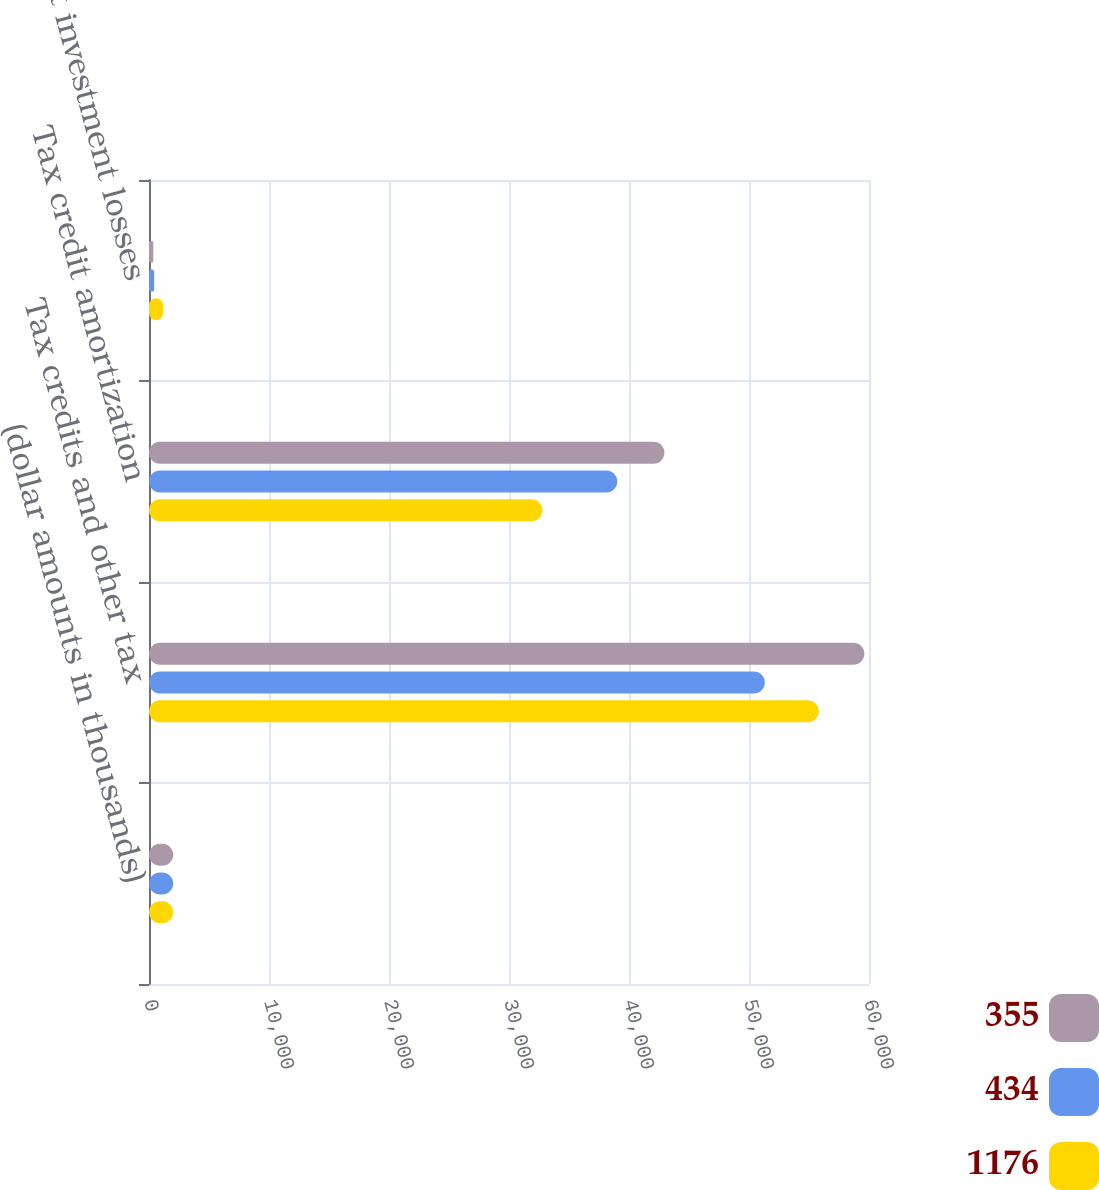<chart> <loc_0><loc_0><loc_500><loc_500><stacked_bar_chart><ecel><fcel>(dollar amounts in thousands)<fcel>Tax credits and other tax<fcel>Tax credit amortization<fcel>Tax credit investment losses<nl><fcel>355<fcel>2015<fcel>59614<fcel>42951<fcel>355<nl><fcel>434<fcel>2014<fcel>51317<fcel>39021<fcel>434<nl><fcel>1176<fcel>2013<fcel>55819<fcel>32789<fcel>1176<nl></chart> 